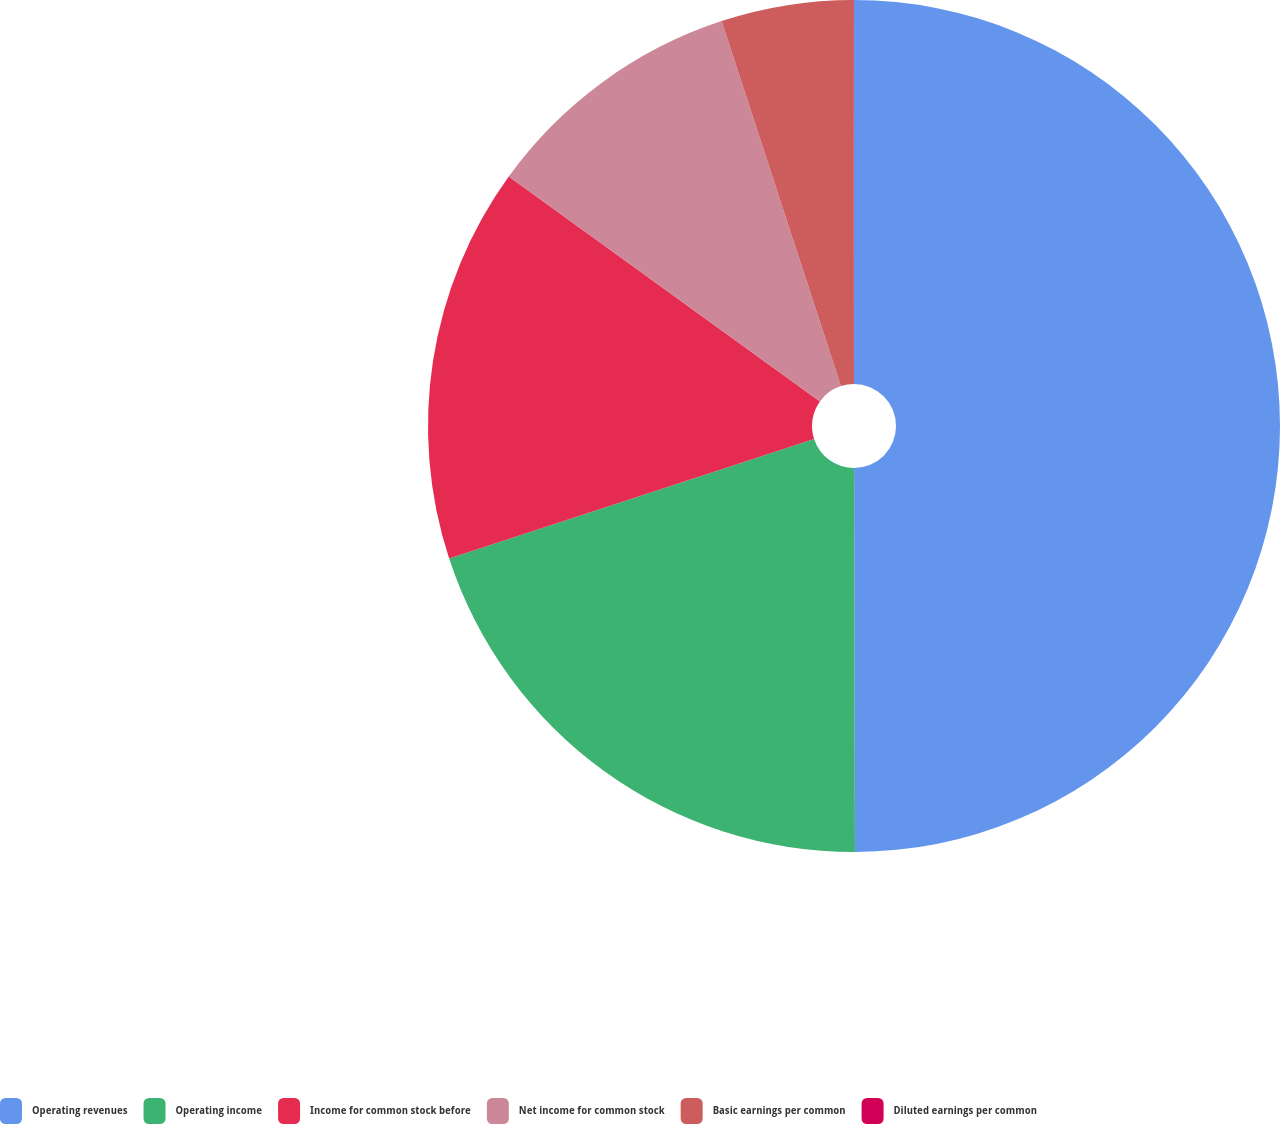Convert chart to OTSL. <chart><loc_0><loc_0><loc_500><loc_500><pie_chart><fcel>Operating revenues<fcel>Operating income<fcel>Income for common stock before<fcel>Net income for common stock<fcel>Basic earnings per common<fcel>Diluted earnings per common<nl><fcel>49.97%<fcel>20.0%<fcel>15.0%<fcel>10.01%<fcel>5.01%<fcel>0.02%<nl></chart> 